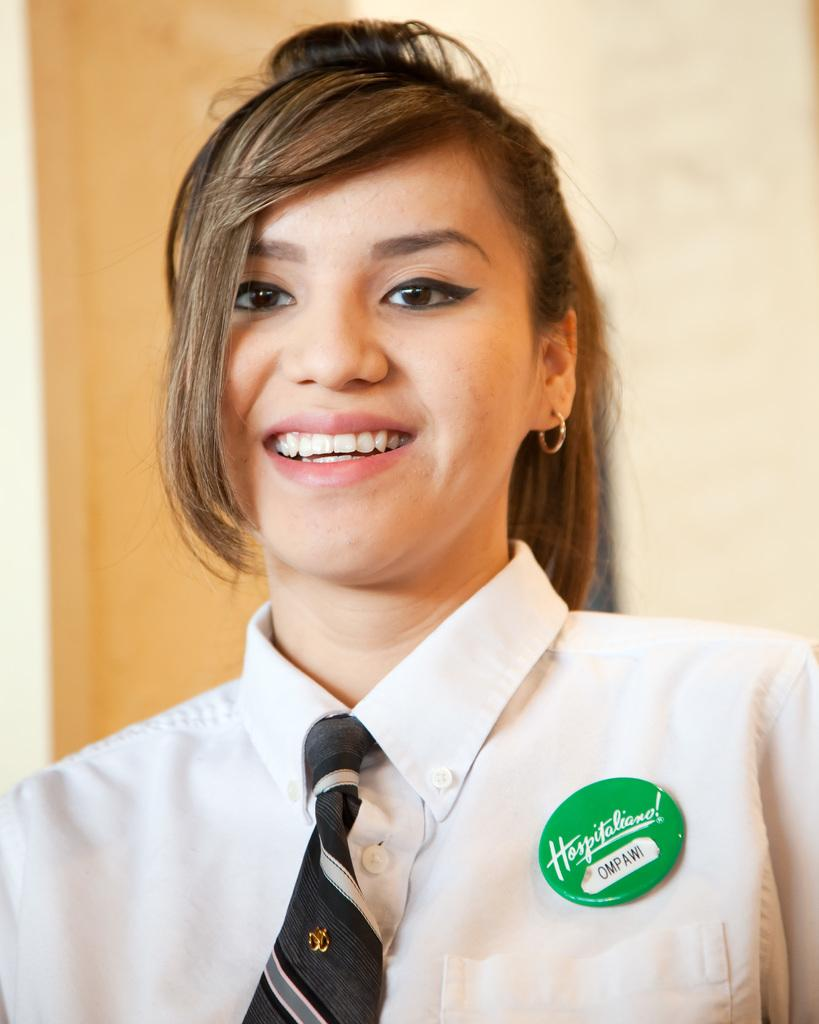<image>
Describe the image concisely. A woman wearing a green nametag with the name Ompawi written on it. 